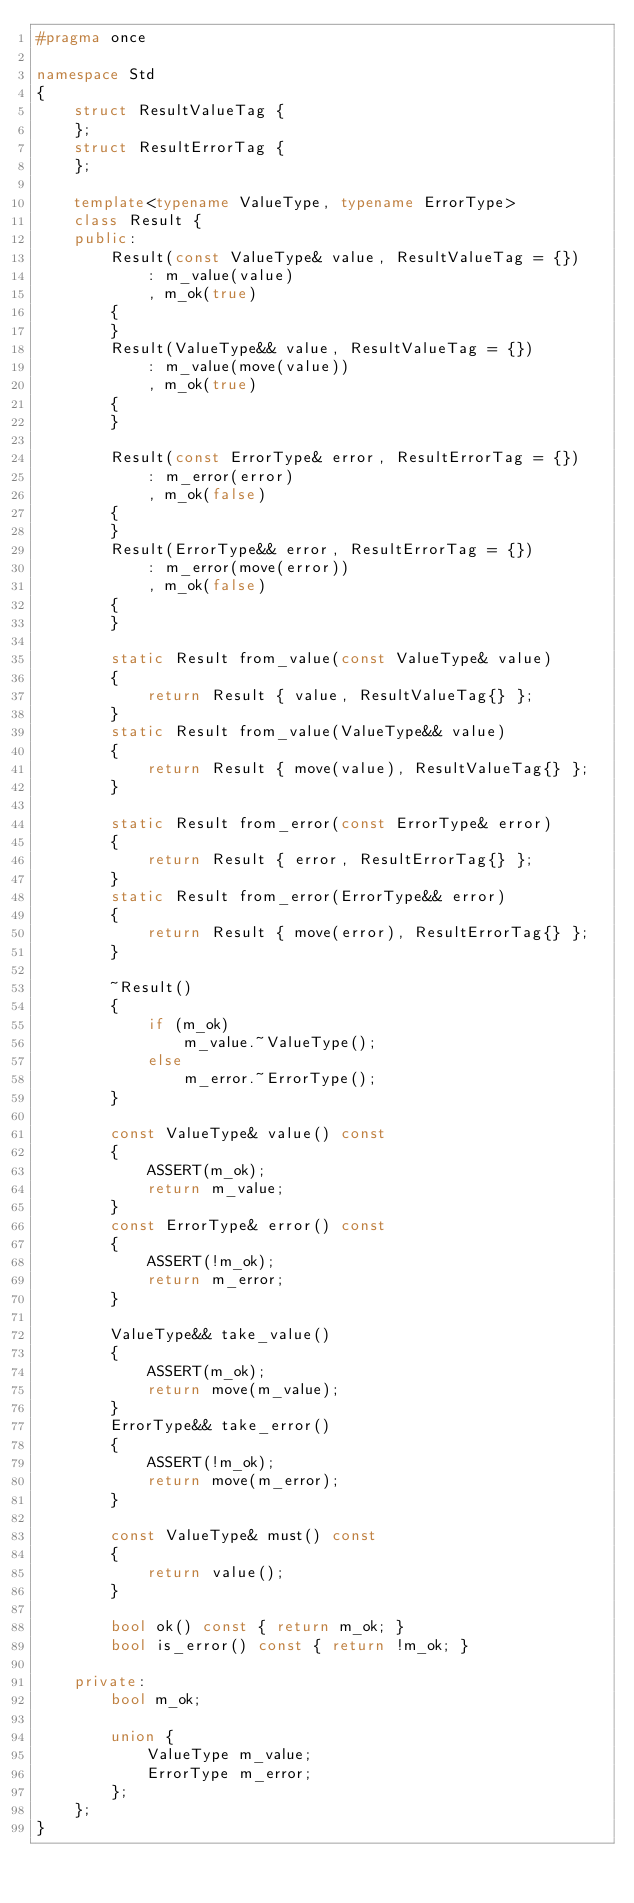Convert code to text. <code><loc_0><loc_0><loc_500><loc_500><_C++_>#pragma once

namespace Std
{
    struct ResultValueTag {
    };
    struct ResultErrorTag {
    };

    template<typename ValueType, typename ErrorType>
    class Result {
    public:
        Result(const ValueType& value, ResultValueTag = {})
            : m_value(value)
            , m_ok(true)
        {
        }
        Result(ValueType&& value, ResultValueTag = {})
            : m_value(move(value))
            , m_ok(true)
        {
        }

        Result(const ErrorType& error, ResultErrorTag = {})
            : m_error(error)
            , m_ok(false)
        {
        }
        Result(ErrorType&& error, ResultErrorTag = {})
            : m_error(move(error))
            , m_ok(false)
        {
        }

        static Result from_value(const ValueType& value)
        {
            return Result { value, ResultValueTag{} };
        }
        static Result from_value(ValueType&& value)
        {
            return Result { move(value), ResultValueTag{} };
        }

        static Result from_error(const ErrorType& error)
        {
            return Result { error, ResultErrorTag{} };
        }
        static Result from_error(ErrorType&& error)
        {
            return Result { move(error), ResultErrorTag{} };
        }

        ~Result()
        {
            if (m_ok)
                m_value.~ValueType();
            else
                m_error.~ErrorType();
        }

        const ValueType& value() const
        {
            ASSERT(m_ok);
            return m_value;
        }
        const ErrorType& error() const
        {
            ASSERT(!m_ok);
            return m_error;
        }

        ValueType&& take_value()
        {
            ASSERT(m_ok);
            return move(m_value);
        }
        ErrorType&& take_error()
        {
            ASSERT(!m_ok);
            return move(m_error);
        }

        const ValueType& must() const
        {
            return value();
        }

        bool ok() const { return m_ok; }
        bool is_error() const { return !m_ok; }

    private:
        bool m_ok;

        union {
            ValueType m_value;
            ErrorType m_error;
        };
    };
}
</code> 